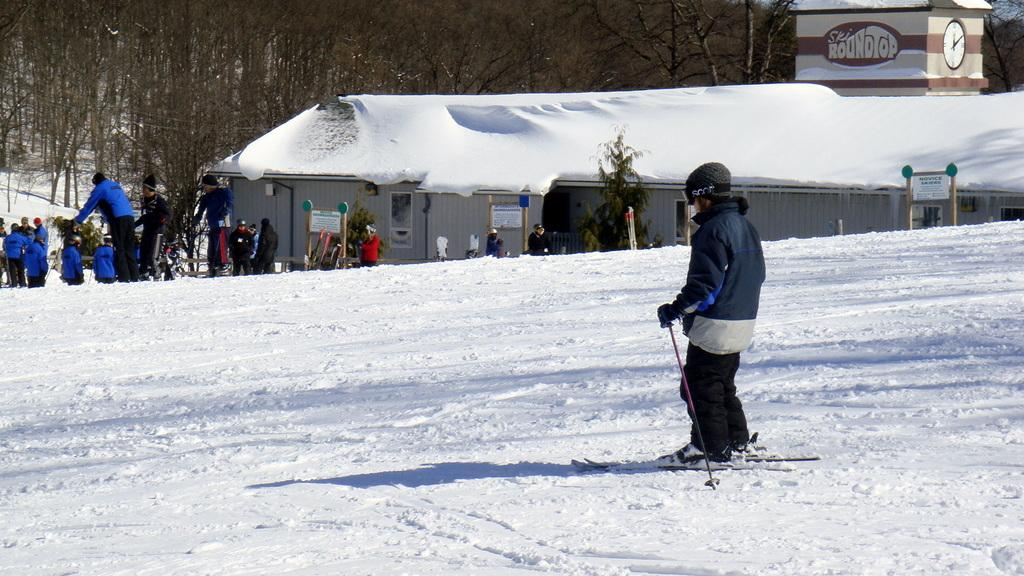What type of structure is visible in the image? There is a house in the image. What object can be seen near the house? There is a box in the image. What time-telling device is present in the image? There is a clock in the image. How many people are in the image? There are people in the image. What weather condition is occurring in the image? It is snowing in the image. What type of vegetation is visible in the background of the image? There are trees in the background of the image. Can you see any geese in the image? There are no geese present in the image. What type of fear is depicted on the faces of the people in the image? There is no indication of fear on the faces of the people in the image. 